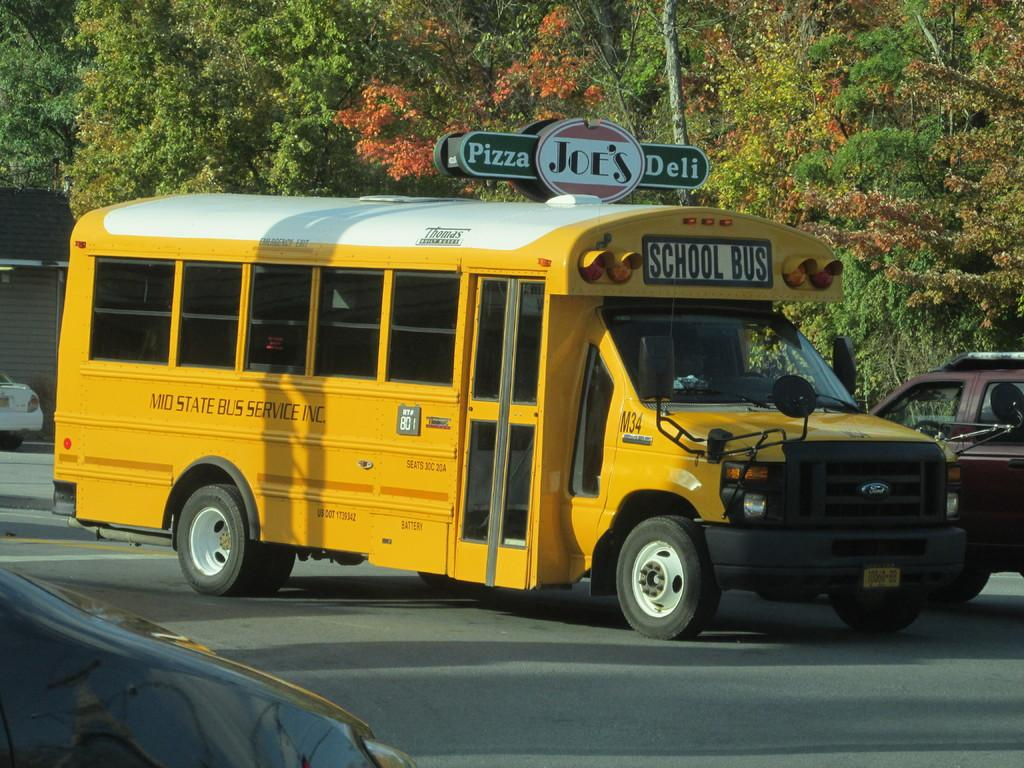<image>
Render a clear and concise summary of the photo. A bus owned by MID STATE BUS SERVICE INC. 